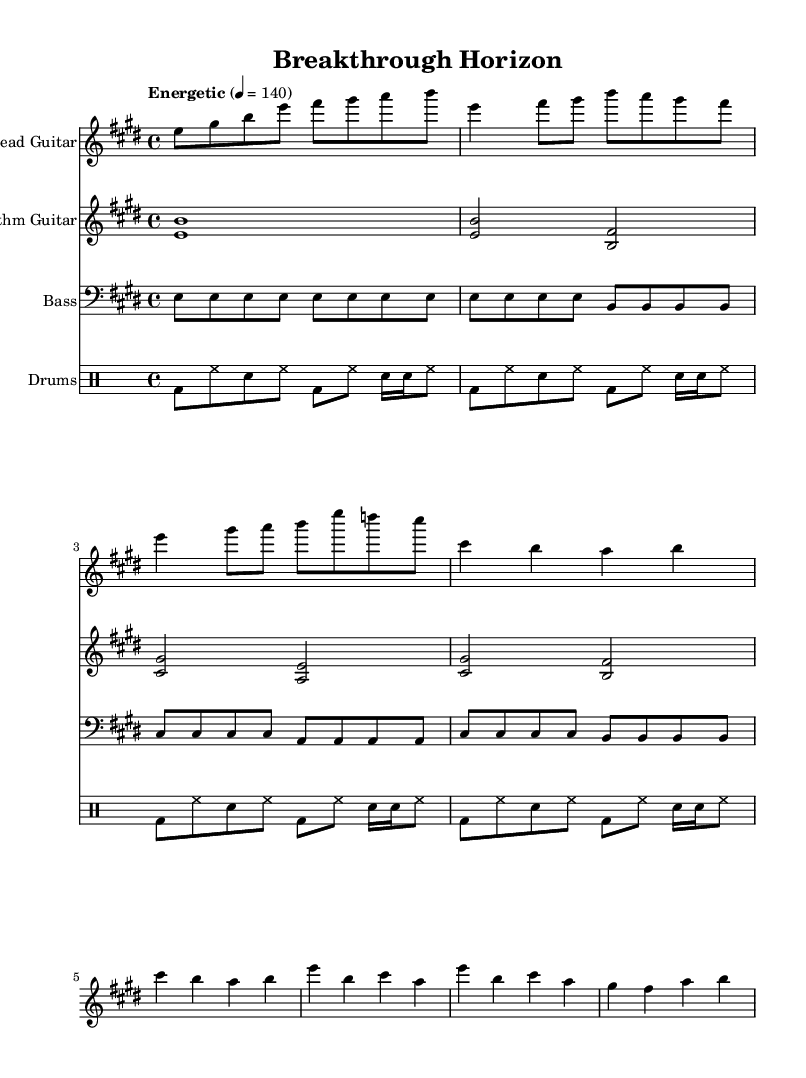What is the key signature of this music? The key signature is E major, which has four sharps (F#, C#, G#, D#).
Answer: E major What is the time signature of this music? The time signature is indicated at the beginning of the score as 4/4, meaning there are four beats in each measure.
Answer: 4/4 What is the tempo marking for this piece? The tempo marking is given as "Energetic" with a metronome marking of 140 beats per minute.
Answer: Energetic, 140 How many measures are in the lead guitar section before the chorus? Counting the measures from the intro through the verse and pre-chorus, there are a total of 6 measures before the chorus begins.
Answer: 6 Which instruments are included in this composition? The instruments listed in the score are Lead Guitar, Rhythm Guitar, Bass, and Drums.
Answer: Lead Guitar, Rhythm Guitar, Bass, Drums What type of chords are used in the rhythm guitar part? The rhythm guitar part utilizes power chords, which are specific chord voicings that emphasize the root and fifth of the chord.
Answer: Power chords What rhythmic pattern is primarily used in the drums part? The drum pattern features a basic rock beat with an energetic eighth note rhythm and some syncopation.
Answer: Basic rock beat 